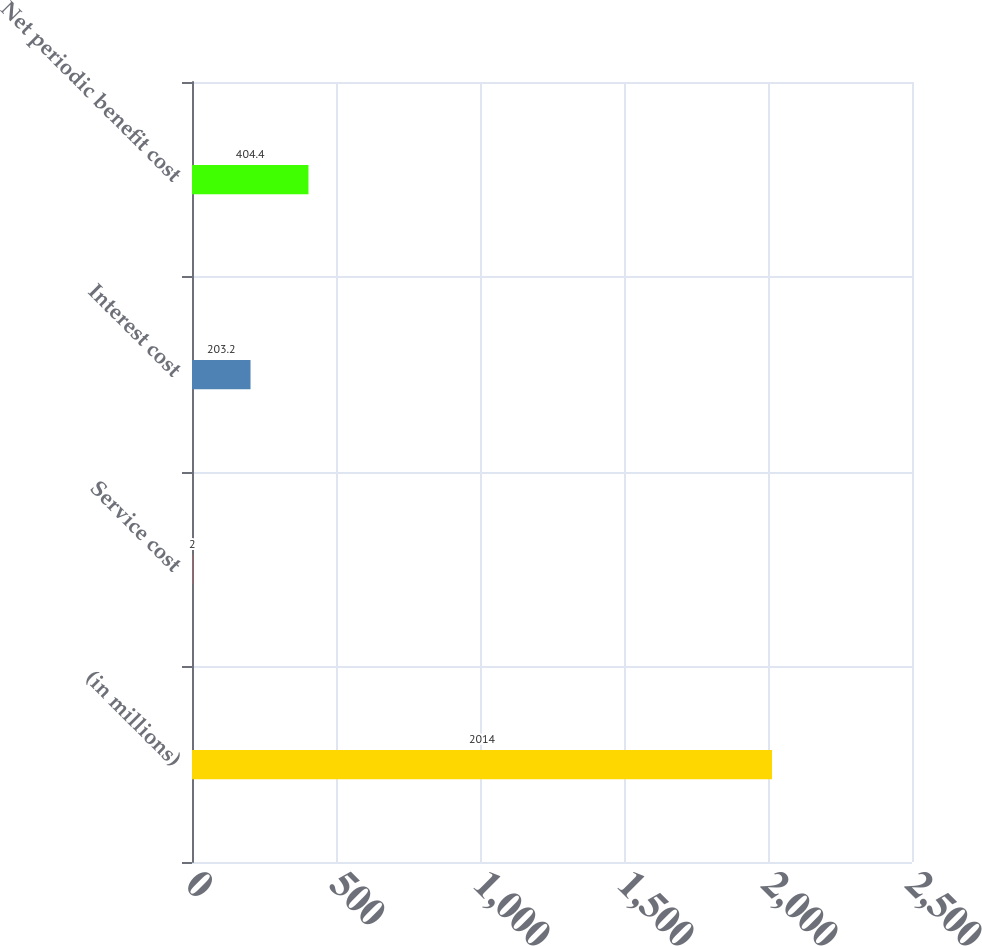<chart> <loc_0><loc_0><loc_500><loc_500><bar_chart><fcel>(in millions)<fcel>Service cost<fcel>Interest cost<fcel>Net periodic benefit cost<nl><fcel>2014<fcel>2<fcel>203.2<fcel>404.4<nl></chart> 